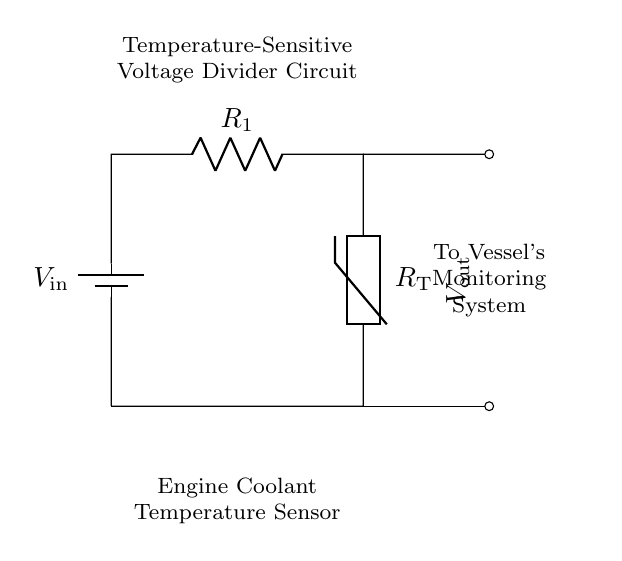What components are in the circuit? The circuit consists of a battery, a resistor, and a thermistor. The battery supplies voltage, the resistor acts as R1, and the thermistor monitors temperature as RT.
Answer: battery, resistor, thermistor What is the purpose of the thermistor in this circuit? The thermistor is used to sense temperature changes in the engine coolant. Its resistance varies with temperature, thus affecting the output voltage which indicates the coolant temperature.
Answer: temperature sensor What is the output voltage referred to as in the diagram? The output voltage is referred to as Vout, indicated in the circuit. This voltage is derived from the voltage divider formed by R1 and RT.
Answer: Vout How is Vout affected by temperature? Vout decreases as the temperature increases due to the decrease in resistance of the thermistor with rising temperature, resulting in a higher current through R1 and thus altering the voltage across RT.
Answer: decreases What type of circuit is this, and what is its primary function? This is a voltage divider circuit. Its primary function is to provide a specific output voltage that is proportional to the temperature sensed by the thermistor.
Answer: voltage divider What is the function of the resistor R1 in this circuit? R1 is used to limit current and create a voltage divider with the thermistor. It helps set the reference for the output voltage based on the resistance of the thermistor.
Answer: current limiting What indicates the engine coolant temperature in this circuit? The change in the output voltage Vout indicates the engine coolant temperature. This voltage is monitored by the vessel's monitoring system to assess the engine temperature.
Answer: Vout 